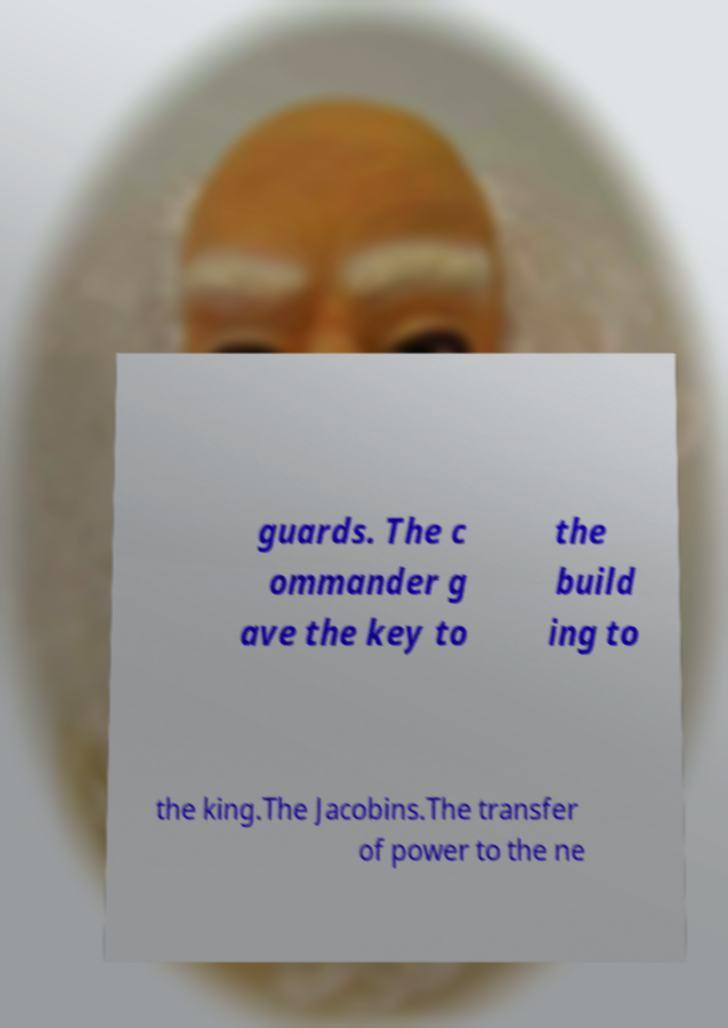Can you accurately transcribe the text from the provided image for me? guards. The c ommander g ave the key to the build ing to the king.The Jacobins.The transfer of power to the ne 